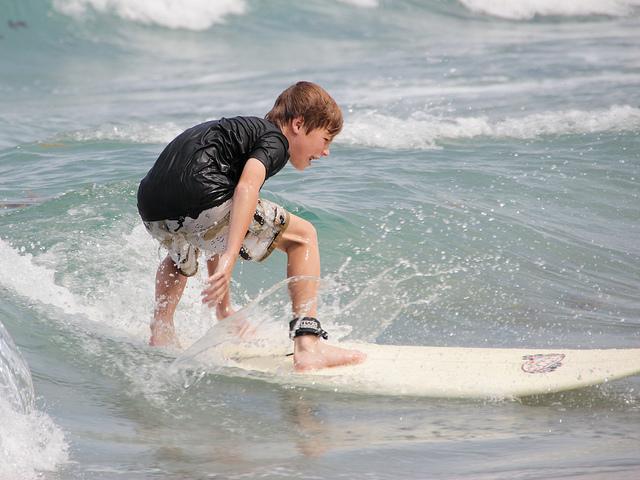What color is the water?
Keep it brief. Green. Is the kid having fun?
Write a very short answer. Yes. Does he appear to be proficient?
Write a very short answer. Yes. Is the boy wet?
Keep it brief. Yes. What is the boy doing with his right hand?
Answer briefly. Balancing. How is the boy tethered to the board?
Write a very short answer. Yes. 